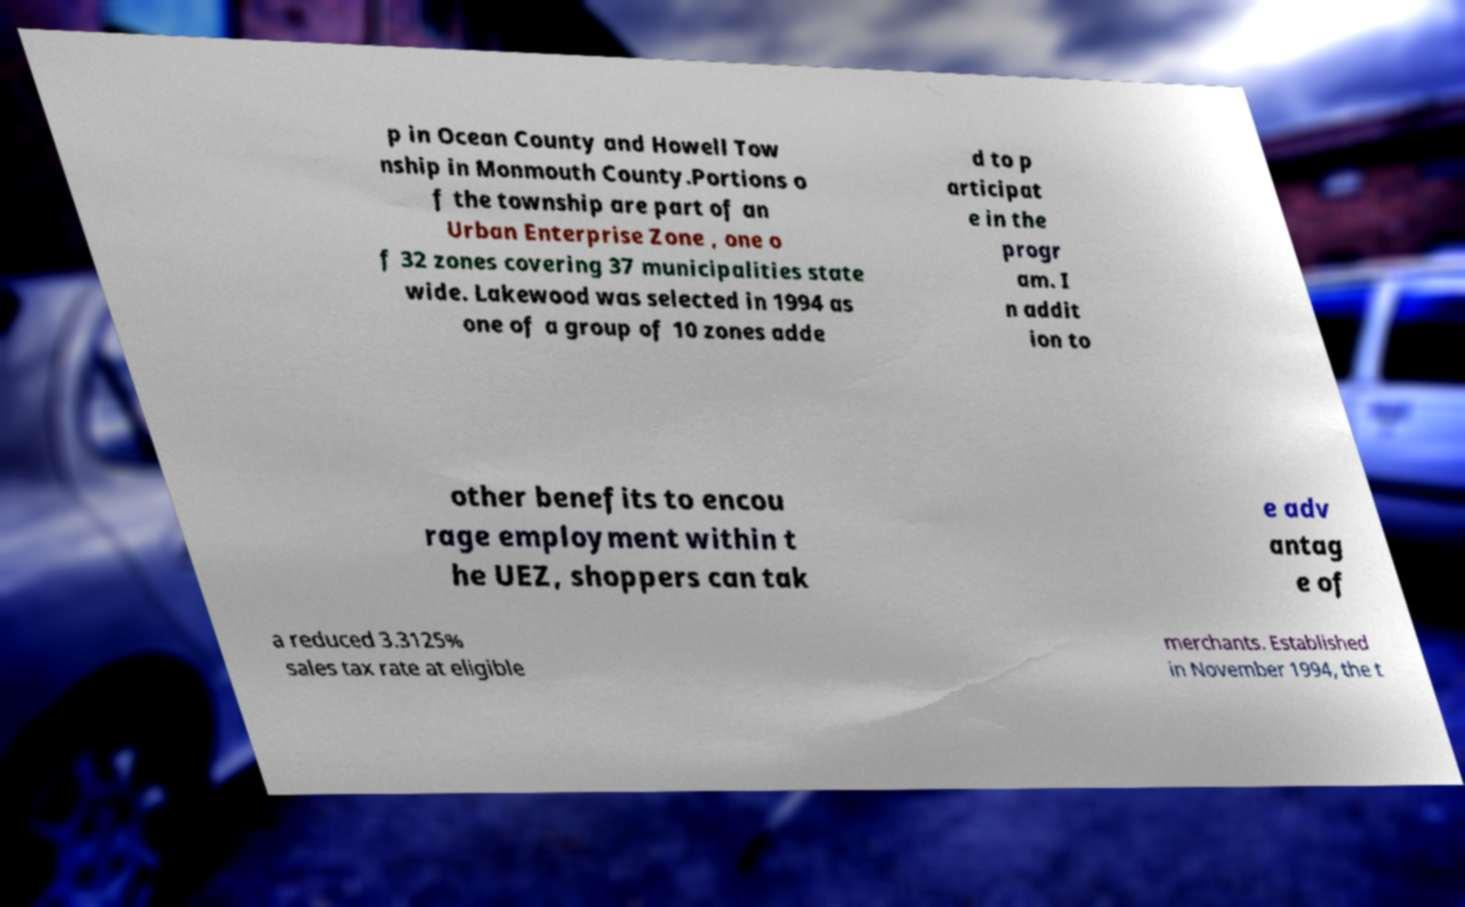Can you accurately transcribe the text from the provided image for me? p in Ocean County and Howell Tow nship in Monmouth County.Portions o f the township are part of an Urban Enterprise Zone , one o f 32 zones covering 37 municipalities state wide. Lakewood was selected in 1994 as one of a group of 10 zones adde d to p articipat e in the progr am. I n addit ion to other benefits to encou rage employment within t he UEZ, shoppers can tak e adv antag e of a reduced 3.3125% sales tax rate at eligible merchants. Established in November 1994, the t 